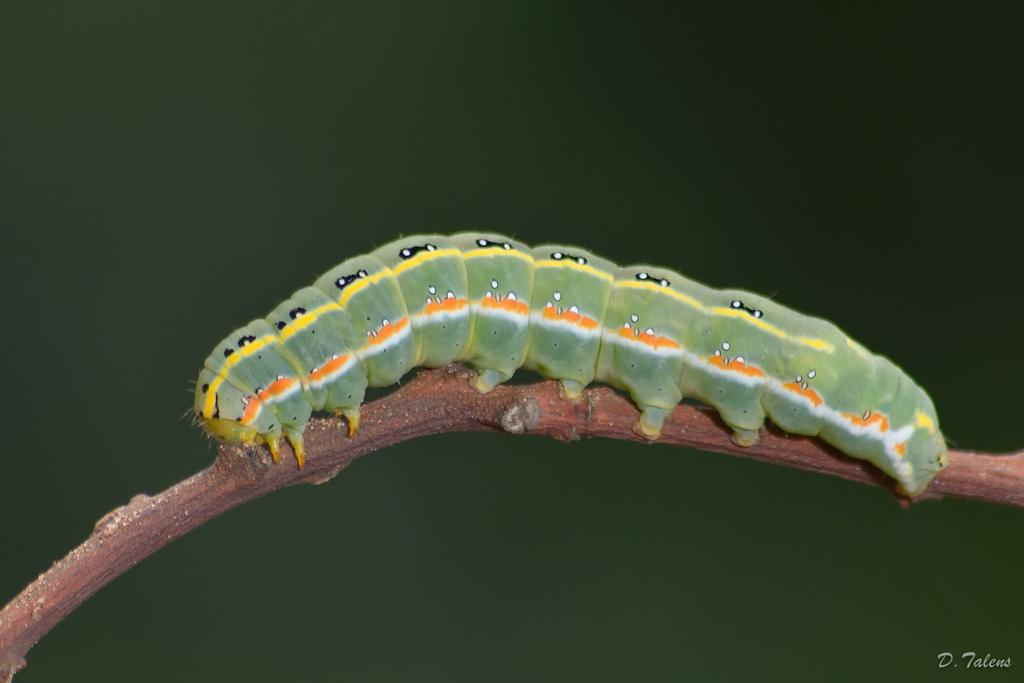What is the main subject of the image? The main subject of the image is a caterpillar on a stem. What color is the background of the image? The background of the image is green. Is there any text present in the image? Yes, there is text at the bottom right of the image. What type of legal advice is the caterpillar seeking in the image? There is no indication in the image that the caterpillar is seeking legal advice or interacting with a lawyer. How much waste is visible in the image? There is no waste visible in the image; it primarily features a caterpillar on a stem and a green background. 